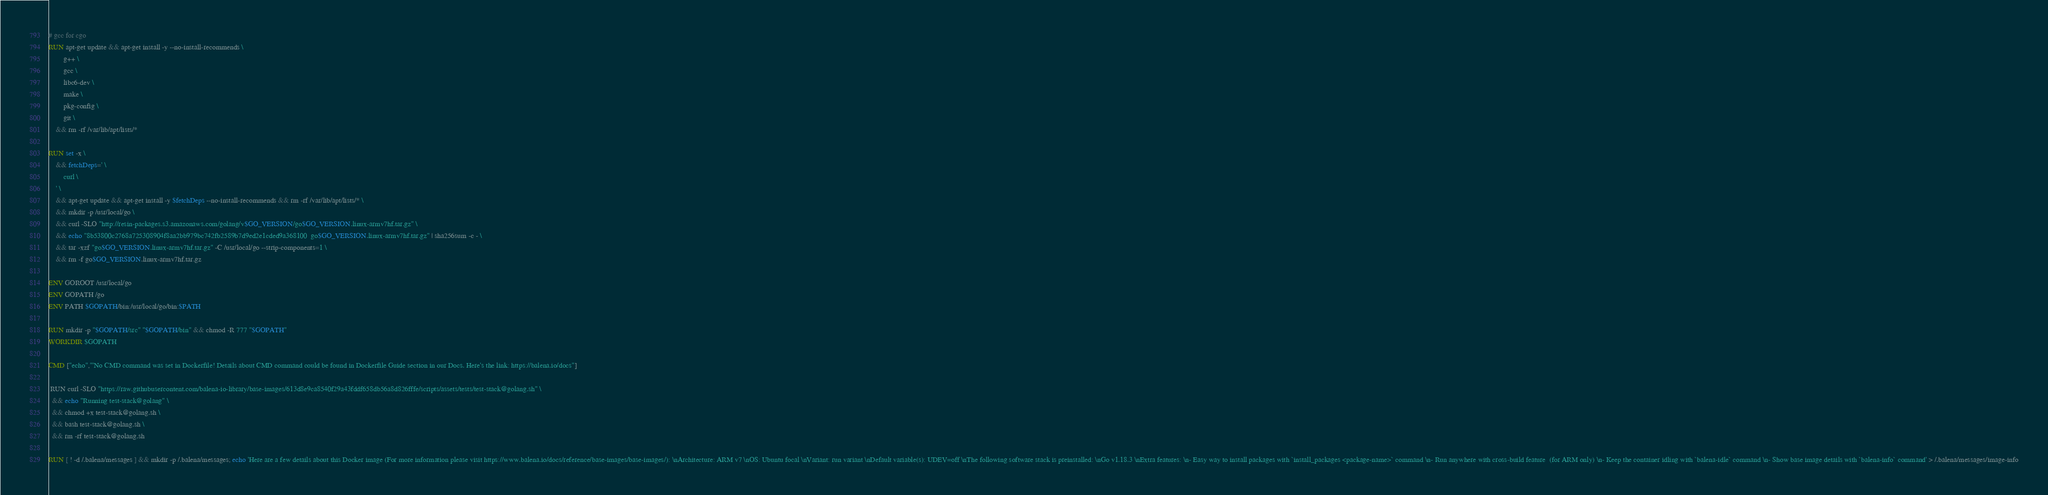<code> <loc_0><loc_0><loc_500><loc_500><_Dockerfile_># gcc for cgo
RUN apt-get update && apt-get install -y --no-install-recommends \
		g++ \
		gcc \
		libc6-dev \
		make \
		pkg-config \
		git \
	&& rm -rf /var/lib/apt/lists/*

RUN set -x \
	&& fetchDeps=' \
		curl \
	' \
	&& apt-get update && apt-get install -y $fetchDeps --no-install-recommends && rm -rf /var/lib/apt/lists/* \
	&& mkdir -p /usr/local/go \
	&& curl -SLO "http://resin-packages.s3.amazonaws.com/golang/v$GO_VERSION/go$GO_VERSION.linux-armv7hf.tar.gz" \
	&& echo "8b53800c2768a725308904f8aa2bb979bc742fb2589b7d9ed2e1cded9a368100  go$GO_VERSION.linux-armv7hf.tar.gz" | sha256sum -c - \
	&& tar -xzf "go$GO_VERSION.linux-armv7hf.tar.gz" -C /usr/local/go --strip-components=1 \
	&& rm -f go$GO_VERSION.linux-armv7hf.tar.gz

ENV GOROOT /usr/local/go
ENV GOPATH /go
ENV PATH $GOPATH/bin:/usr/local/go/bin:$PATH

RUN mkdir -p "$GOPATH/src" "$GOPATH/bin" && chmod -R 777 "$GOPATH"
WORKDIR $GOPATH

CMD ["echo","'No CMD command was set in Dockerfile! Details about CMD command could be found in Dockerfile Guide section in our Docs. Here's the link: https://balena.io/docs"]

 RUN curl -SLO "https://raw.githubusercontent.com/balena-io-library/base-images/613d8e9ca8540f29a43fddf658db56a8d826fffe/scripts/assets/tests/test-stack@golang.sh" \
  && echo "Running test-stack@golang" \
  && chmod +x test-stack@golang.sh \
  && bash test-stack@golang.sh \
  && rm -rf test-stack@golang.sh 

RUN [ ! -d /.balena/messages ] && mkdir -p /.balena/messages; echo 'Here are a few details about this Docker image (For more information please visit https://www.balena.io/docs/reference/base-images/base-images/): \nArchitecture: ARM v7 \nOS: Ubuntu focal \nVariant: run variant \nDefault variable(s): UDEV=off \nThe following software stack is preinstalled: \nGo v1.18.3 \nExtra features: \n- Easy way to install packages with `install_packages <package-name>` command \n- Run anywhere with cross-build feature  (for ARM only) \n- Keep the container idling with `balena-idle` command \n- Show base image details with `balena-info` command' > /.balena/messages/image-info</code> 